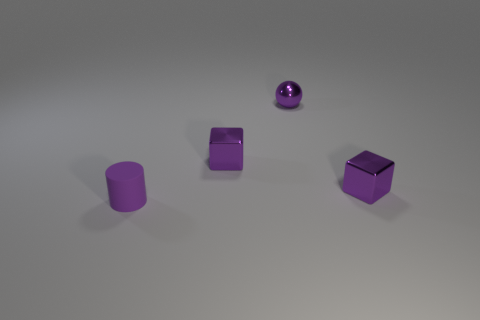Add 4 tiny blue cylinders. How many objects exist? 8 Subtract all spheres. How many objects are left? 3 Add 1 small balls. How many small balls exist? 2 Subtract 0 cyan balls. How many objects are left? 4 Subtract 1 blocks. How many blocks are left? 1 Subtract all cyan blocks. Subtract all gray cylinders. How many blocks are left? 2 Subtract all brown spheres. How many brown cylinders are left? 0 Subtract all cyan objects. Subtract all small purple spheres. How many objects are left? 3 Add 4 cubes. How many cubes are left? 6 